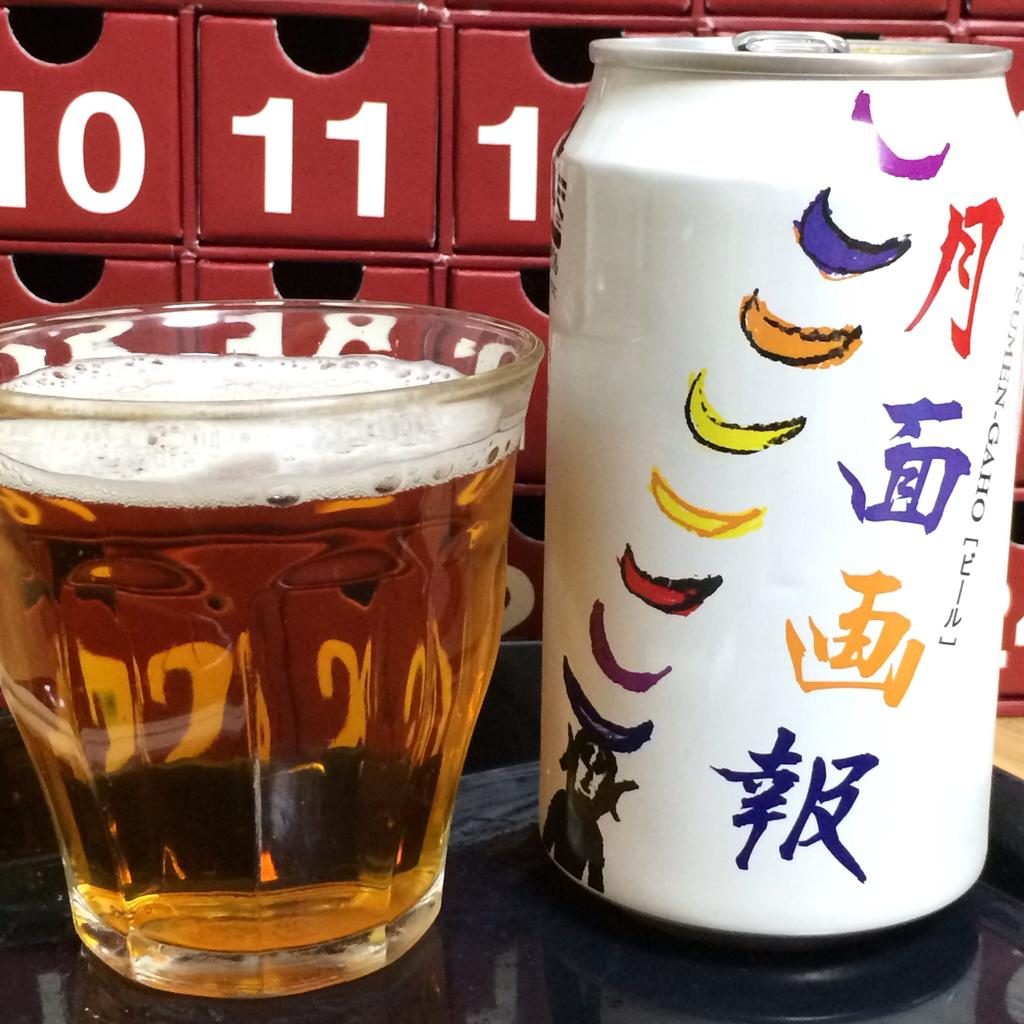<image>
Summarize the visual content of the image. A can of beer from Japan in front of the numbers 10 and 11 on a red tray 